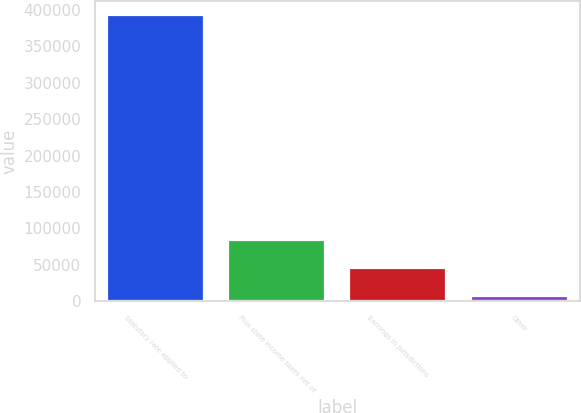Convert chart to OTSL. <chart><loc_0><loc_0><loc_500><loc_500><bar_chart><fcel>Statutory rate applied to<fcel>Plus state income taxes net of<fcel>Earnings in jurisdictions<fcel>Other<nl><fcel>393288<fcel>83756.8<fcel>45065.4<fcel>6374<nl></chart> 